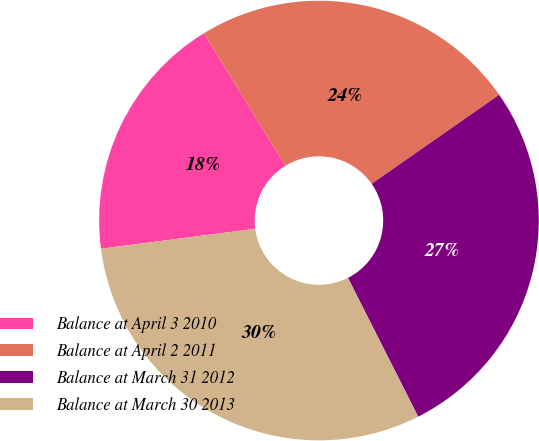Convert chart. <chart><loc_0><loc_0><loc_500><loc_500><pie_chart><fcel>Balance at April 3 2010<fcel>Balance at April 2 2011<fcel>Balance at March 31 2012<fcel>Balance at March 30 2013<nl><fcel>18.28%<fcel>24.07%<fcel>27.24%<fcel>30.41%<nl></chart> 